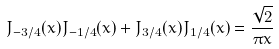<formula> <loc_0><loc_0><loc_500><loc_500>J _ { - 3 / 4 } ( x ) J _ { - 1 / 4 } ( x ) + J _ { 3 / 4 } ( x ) J _ { 1 / 4 } ( x ) = \frac { \sqrt { 2 } } { \pi x }</formula> 